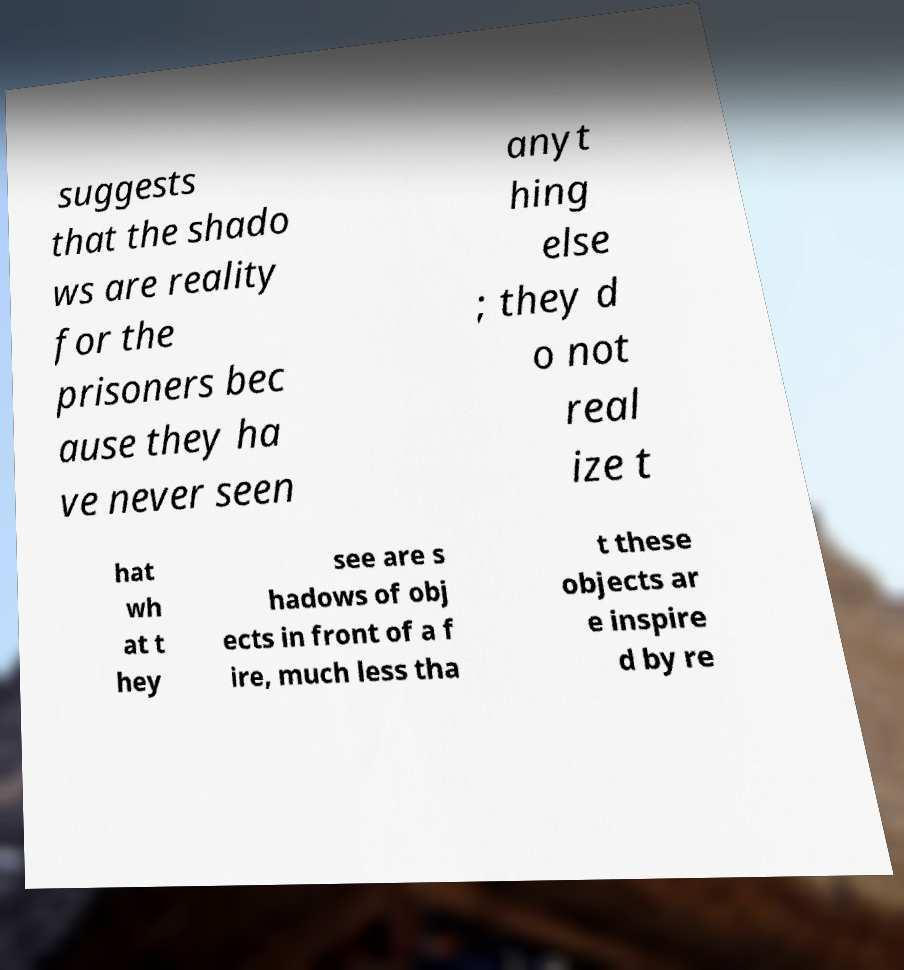Please identify and transcribe the text found in this image. suggests that the shado ws are reality for the prisoners bec ause they ha ve never seen anyt hing else ; they d o not real ize t hat wh at t hey see are s hadows of obj ects in front of a f ire, much less tha t these objects ar e inspire d by re 